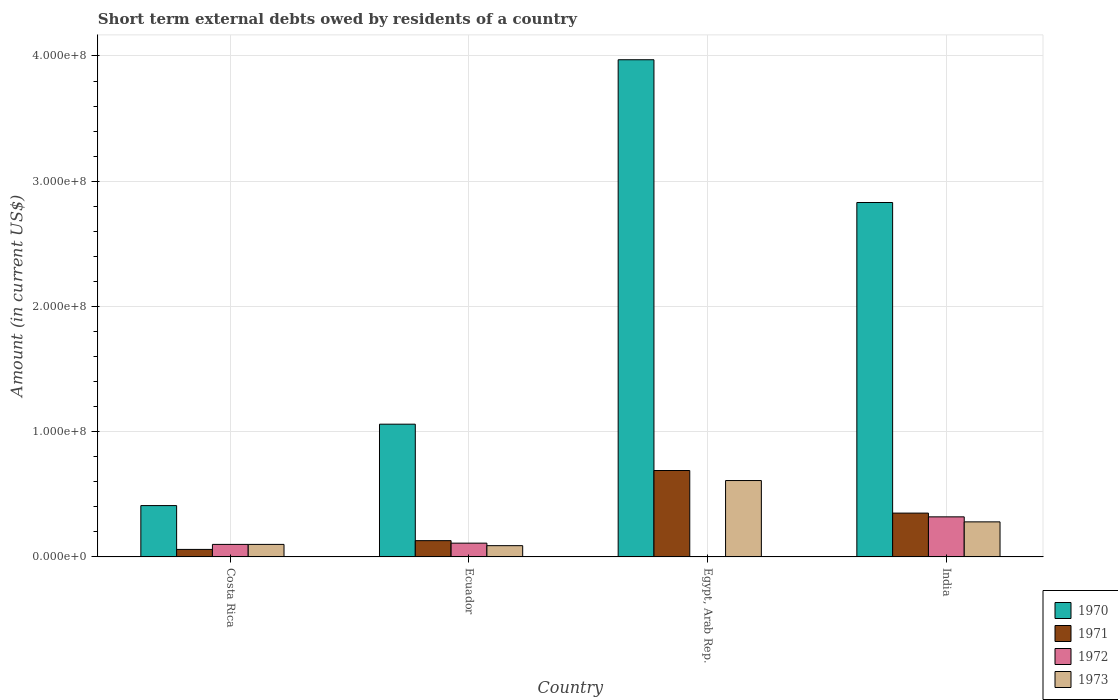How many different coloured bars are there?
Give a very brief answer. 4. Are the number of bars per tick equal to the number of legend labels?
Offer a very short reply. No. Are the number of bars on each tick of the X-axis equal?
Your answer should be very brief. No. What is the label of the 3rd group of bars from the left?
Your answer should be compact. Egypt, Arab Rep. What is the amount of short-term external debts owed by residents in 1970 in India?
Offer a terse response. 2.83e+08. Across all countries, what is the maximum amount of short-term external debts owed by residents in 1972?
Your answer should be very brief. 3.20e+07. Across all countries, what is the minimum amount of short-term external debts owed by residents in 1972?
Your answer should be very brief. 0. In which country was the amount of short-term external debts owed by residents in 1971 maximum?
Your response must be concise. Egypt, Arab Rep. What is the total amount of short-term external debts owed by residents in 1973 in the graph?
Keep it short and to the point. 1.08e+08. What is the difference between the amount of short-term external debts owed by residents in 1973 in Costa Rica and that in India?
Your response must be concise. -1.80e+07. What is the difference between the amount of short-term external debts owed by residents in 1971 in Costa Rica and the amount of short-term external debts owed by residents in 1970 in Ecuador?
Make the answer very short. -1.00e+08. What is the average amount of short-term external debts owed by residents in 1970 per country?
Keep it short and to the point. 2.07e+08. What is the difference between the amount of short-term external debts owed by residents of/in 1970 and amount of short-term external debts owed by residents of/in 1973 in India?
Offer a very short reply. 2.55e+08. What is the ratio of the amount of short-term external debts owed by residents in 1972 in Ecuador to that in India?
Offer a terse response. 0.34. What is the difference between the highest and the second highest amount of short-term external debts owed by residents in 1971?
Make the answer very short. 5.60e+07. What is the difference between the highest and the lowest amount of short-term external debts owed by residents in 1971?
Provide a short and direct response. 6.30e+07. Is the sum of the amount of short-term external debts owed by residents in 1970 in Ecuador and India greater than the maximum amount of short-term external debts owed by residents in 1972 across all countries?
Make the answer very short. Yes. Is it the case that in every country, the sum of the amount of short-term external debts owed by residents in 1971 and amount of short-term external debts owed by residents in 1973 is greater than the amount of short-term external debts owed by residents in 1972?
Give a very brief answer. Yes. How many bars are there?
Your response must be concise. 15. How many countries are there in the graph?
Your response must be concise. 4. What is the difference between two consecutive major ticks on the Y-axis?
Offer a terse response. 1.00e+08. How many legend labels are there?
Offer a terse response. 4. What is the title of the graph?
Ensure brevity in your answer.  Short term external debts owed by residents of a country. What is the label or title of the X-axis?
Provide a succinct answer. Country. What is the Amount (in current US$) of 1970 in Costa Rica?
Offer a terse response. 4.10e+07. What is the Amount (in current US$) in 1971 in Costa Rica?
Offer a very short reply. 6.00e+06. What is the Amount (in current US$) of 1970 in Ecuador?
Ensure brevity in your answer.  1.06e+08. What is the Amount (in current US$) of 1971 in Ecuador?
Make the answer very short. 1.30e+07. What is the Amount (in current US$) of 1972 in Ecuador?
Offer a terse response. 1.10e+07. What is the Amount (in current US$) of 1973 in Ecuador?
Offer a terse response. 9.00e+06. What is the Amount (in current US$) of 1970 in Egypt, Arab Rep.?
Your answer should be very brief. 3.97e+08. What is the Amount (in current US$) in 1971 in Egypt, Arab Rep.?
Provide a short and direct response. 6.90e+07. What is the Amount (in current US$) of 1973 in Egypt, Arab Rep.?
Your answer should be very brief. 6.10e+07. What is the Amount (in current US$) of 1970 in India?
Ensure brevity in your answer.  2.83e+08. What is the Amount (in current US$) in 1971 in India?
Your response must be concise. 3.50e+07. What is the Amount (in current US$) of 1972 in India?
Provide a succinct answer. 3.20e+07. What is the Amount (in current US$) in 1973 in India?
Offer a very short reply. 2.80e+07. Across all countries, what is the maximum Amount (in current US$) of 1970?
Give a very brief answer. 3.97e+08. Across all countries, what is the maximum Amount (in current US$) in 1971?
Give a very brief answer. 6.90e+07. Across all countries, what is the maximum Amount (in current US$) of 1972?
Your answer should be compact. 3.20e+07. Across all countries, what is the maximum Amount (in current US$) in 1973?
Your response must be concise. 6.10e+07. Across all countries, what is the minimum Amount (in current US$) in 1970?
Make the answer very short. 4.10e+07. Across all countries, what is the minimum Amount (in current US$) of 1971?
Keep it short and to the point. 6.00e+06. Across all countries, what is the minimum Amount (in current US$) in 1972?
Keep it short and to the point. 0. Across all countries, what is the minimum Amount (in current US$) of 1973?
Your response must be concise. 9.00e+06. What is the total Amount (in current US$) in 1970 in the graph?
Keep it short and to the point. 8.27e+08. What is the total Amount (in current US$) in 1971 in the graph?
Keep it short and to the point. 1.23e+08. What is the total Amount (in current US$) of 1972 in the graph?
Ensure brevity in your answer.  5.30e+07. What is the total Amount (in current US$) in 1973 in the graph?
Give a very brief answer. 1.08e+08. What is the difference between the Amount (in current US$) in 1970 in Costa Rica and that in Ecuador?
Your response must be concise. -6.50e+07. What is the difference between the Amount (in current US$) in 1971 in Costa Rica and that in Ecuador?
Offer a terse response. -7.00e+06. What is the difference between the Amount (in current US$) in 1970 in Costa Rica and that in Egypt, Arab Rep.?
Provide a short and direct response. -3.56e+08. What is the difference between the Amount (in current US$) of 1971 in Costa Rica and that in Egypt, Arab Rep.?
Your answer should be very brief. -6.30e+07. What is the difference between the Amount (in current US$) of 1973 in Costa Rica and that in Egypt, Arab Rep.?
Your answer should be compact. -5.10e+07. What is the difference between the Amount (in current US$) in 1970 in Costa Rica and that in India?
Offer a very short reply. -2.42e+08. What is the difference between the Amount (in current US$) in 1971 in Costa Rica and that in India?
Provide a short and direct response. -2.90e+07. What is the difference between the Amount (in current US$) of 1972 in Costa Rica and that in India?
Offer a very short reply. -2.20e+07. What is the difference between the Amount (in current US$) in 1973 in Costa Rica and that in India?
Give a very brief answer. -1.80e+07. What is the difference between the Amount (in current US$) in 1970 in Ecuador and that in Egypt, Arab Rep.?
Keep it short and to the point. -2.91e+08. What is the difference between the Amount (in current US$) of 1971 in Ecuador and that in Egypt, Arab Rep.?
Your response must be concise. -5.60e+07. What is the difference between the Amount (in current US$) of 1973 in Ecuador and that in Egypt, Arab Rep.?
Offer a terse response. -5.20e+07. What is the difference between the Amount (in current US$) in 1970 in Ecuador and that in India?
Make the answer very short. -1.77e+08. What is the difference between the Amount (in current US$) of 1971 in Ecuador and that in India?
Keep it short and to the point. -2.20e+07. What is the difference between the Amount (in current US$) in 1972 in Ecuador and that in India?
Offer a terse response. -2.10e+07. What is the difference between the Amount (in current US$) in 1973 in Ecuador and that in India?
Give a very brief answer. -1.90e+07. What is the difference between the Amount (in current US$) in 1970 in Egypt, Arab Rep. and that in India?
Your response must be concise. 1.14e+08. What is the difference between the Amount (in current US$) of 1971 in Egypt, Arab Rep. and that in India?
Your answer should be compact. 3.40e+07. What is the difference between the Amount (in current US$) in 1973 in Egypt, Arab Rep. and that in India?
Give a very brief answer. 3.30e+07. What is the difference between the Amount (in current US$) of 1970 in Costa Rica and the Amount (in current US$) of 1971 in Ecuador?
Your answer should be very brief. 2.80e+07. What is the difference between the Amount (in current US$) of 1970 in Costa Rica and the Amount (in current US$) of 1972 in Ecuador?
Ensure brevity in your answer.  3.00e+07. What is the difference between the Amount (in current US$) of 1970 in Costa Rica and the Amount (in current US$) of 1973 in Ecuador?
Make the answer very short. 3.20e+07. What is the difference between the Amount (in current US$) of 1971 in Costa Rica and the Amount (in current US$) of 1972 in Ecuador?
Offer a very short reply. -5.00e+06. What is the difference between the Amount (in current US$) of 1971 in Costa Rica and the Amount (in current US$) of 1973 in Ecuador?
Keep it short and to the point. -3.00e+06. What is the difference between the Amount (in current US$) of 1970 in Costa Rica and the Amount (in current US$) of 1971 in Egypt, Arab Rep.?
Provide a succinct answer. -2.80e+07. What is the difference between the Amount (in current US$) in 1970 in Costa Rica and the Amount (in current US$) in 1973 in Egypt, Arab Rep.?
Offer a very short reply. -2.00e+07. What is the difference between the Amount (in current US$) of 1971 in Costa Rica and the Amount (in current US$) of 1973 in Egypt, Arab Rep.?
Your answer should be very brief. -5.50e+07. What is the difference between the Amount (in current US$) in 1972 in Costa Rica and the Amount (in current US$) in 1973 in Egypt, Arab Rep.?
Your answer should be compact. -5.10e+07. What is the difference between the Amount (in current US$) in 1970 in Costa Rica and the Amount (in current US$) in 1971 in India?
Give a very brief answer. 6.00e+06. What is the difference between the Amount (in current US$) of 1970 in Costa Rica and the Amount (in current US$) of 1972 in India?
Keep it short and to the point. 9.00e+06. What is the difference between the Amount (in current US$) in 1970 in Costa Rica and the Amount (in current US$) in 1973 in India?
Your answer should be compact. 1.30e+07. What is the difference between the Amount (in current US$) of 1971 in Costa Rica and the Amount (in current US$) of 1972 in India?
Ensure brevity in your answer.  -2.60e+07. What is the difference between the Amount (in current US$) in 1971 in Costa Rica and the Amount (in current US$) in 1973 in India?
Provide a succinct answer. -2.20e+07. What is the difference between the Amount (in current US$) in 1972 in Costa Rica and the Amount (in current US$) in 1973 in India?
Provide a succinct answer. -1.80e+07. What is the difference between the Amount (in current US$) in 1970 in Ecuador and the Amount (in current US$) in 1971 in Egypt, Arab Rep.?
Provide a succinct answer. 3.70e+07. What is the difference between the Amount (in current US$) of 1970 in Ecuador and the Amount (in current US$) of 1973 in Egypt, Arab Rep.?
Your response must be concise. 4.50e+07. What is the difference between the Amount (in current US$) in 1971 in Ecuador and the Amount (in current US$) in 1973 in Egypt, Arab Rep.?
Your answer should be compact. -4.80e+07. What is the difference between the Amount (in current US$) of 1972 in Ecuador and the Amount (in current US$) of 1973 in Egypt, Arab Rep.?
Your answer should be very brief. -5.00e+07. What is the difference between the Amount (in current US$) in 1970 in Ecuador and the Amount (in current US$) in 1971 in India?
Offer a very short reply. 7.10e+07. What is the difference between the Amount (in current US$) of 1970 in Ecuador and the Amount (in current US$) of 1972 in India?
Give a very brief answer. 7.40e+07. What is the difference between the Amount (in current US$) in 1970 in Ecuador and the Amount (in current US$) in 1973 in India?
Offer a terse response. 7.80e+07. What is the difference between the Amount (in current US$) in 1971 in Ecuador and the Amount (in current US$) in 1972 in India?
Give a very brief answer. -1.90e+07. What is the difference between the Amount (in current US$) of 1971 in Ecuador and the Amount (in current US$) of 1973 in India?
Offer a very short reply. -1.50e+07. What is the difference between the Amount (in current US$) of 1972 in Ecuador and the Amount (in current US$) of 1973 in India?
Make the answer very short. -1.70e+07. What is the difference between the Amount (in current US$) of 1970 in Egypt, Arab Rep. and the Amount (in current US$) of 1971 in India?
Give a very brief answer. 3.62e+08. What is the difference between the Amount (in current US$) in 1970 in Egypt, Arab Rep. and the Amount (in current US$) in 1972 in India?
Offer a terse response. 3.65e+08. What is the difference between the Amount (in current US$) of 1970 in Egypt, Arab Rep. and the Amount (in current US$) of 1973 in India?
Your answer should be compact. 3.69e+08. What is the difference between the Amount (in current US$) in 1971 in Egypt, Arab Rep. and the Amount (in current US$) in 1972 in India?
Provide a succinct answer. 3.70e+07. What is the difference between the Amount (in current US$) in 1971 in Egypt, Arab Rep. and the Amount (in current US$) in 1973 in India?
Offer a terse response. 4.10e+07. What is the average Amount (in current US$) in 1970 per country?
Your answer should be compact. 2.07e+08. What is the average Amount (in current US$) of 1971 per country?
Your response must be concise. 3.08e+07. What is the average Amount (in current US$) of 1972 per country?
Your answer should be very brief. 1.32e+07. What is the average Amount (in current US$) of 1973 per country?
Offer a terse response. 2.70e+07. What is the difference between the Amount (in current US$) in 1970 and Amount (in current US$) in 1971 in Costa Rica?
Give a very brief answer. 3.50e+07. What is the difference between the Amount (in current US$) in 1970 and Amount (in current US$) in 1972 in Costa Rica?
Your response must be concise. 3.10e+07. What is the difference between the Amount (in current US$) in 1970 and Amount (in current US$) in 1973 in Costa Rica?
Ensure brevity in your answer.  3.10e+07. What is the difference between the Amount (in current US$) of 1971 and Amount (in current US$) of 1972 in Costa Rica?
Ensure brevity in your answer.  -4.00e+06. What is the difference between the Amount (in current US$) in 1972 and Amount (in current US$) in 1973 in Costa Rica?
Provide a short and direct response. 0. What is the difference between the Amount (in current US$) of 1970 and Amount (in current US$) of 1971 in Ecuador?
Your response must be concise. 9.30e+07. What is the difference between the Amount (in current US$) in 1970 and Amount (in current US$) in 1972 in Ecuador?
Your answer should be very brief. 9.50e+07. What is the difference between the Amount (in current US$) of 1970 and Amount (in current US$) of 1973 in Ecuador?
Offer a terse response. 9.70e+07. What is the difference between the Amount (in current US$) of 1970 and Amount (in current US$) of 1971 in Egypt, Arab Rep.?
Offer a very short reply. 3.28e+08. What is the difference between the Amount (in current US$) of 1970 and Amount (in current US$) of 1973 in Egypt, Arab Rep.?
Provide a succinct answer. 3.36e+08. What is the difference between the Amount (in current US$) of 1970 and Amount (in current US$) of 1971 in India?
Offer a terse response. 2.48e+08. What is the difference between the Amount (in current US$) of 1970 and Amount (in current US$) of 1972 in India?
Give a very brief answer. 2.51e+08. What is the difference between the Amount (in current US$) of 1970 and Amount (in current US$) of 1973 in India?
Your response must be concise. 2.55e+08. What is the difference between the Amount (in current US$) in 1971 and Amount (in current US$) in 1973 in India?
Give a very brief answer. 7.00e+06. What is the ratio of the Amount (in current US$) in 1970 in Costa Rica to that in Ecuador?
Make the answer very short. 0.39. What is the ratio of the Amount (in current US$) of 1971 in Costa Rica to that in Ecuador?
Provide a short and direct response. 0.46. What is the ratio of the Amount (in current US$) of 1973 in Costa Rica to that in Ecuador?
Make the answer very short. 1.11. What is the ratio of the Amount (in current US$) in 1970 in Costa Rica to that in Egypt, Arab Rep.?
Offer a terse response. 0.1. What is the ratio of the Amount (in current US$) in 1971 in Costa Rica to that in Egypt, Arab Rep.?
Provide a succinct answer. 0.09. What is the ratio of the Amount (in current US$) in 1973 in Costa Rica to that in Egypt, Arab Rep.?
Your response must be concise. 0.16. What is the ratio of the Amount (in current US$) in 1970 in Costa Rica to that in India?
Make the answer very short. 0.14. What is the ratio of the Amount (in current US$) of 1971 in Costa Rica to that in India?
Keep it short and to the point. 0.17. What is the ratio of the Amount (in current US$) in 1972 in Costa Rica to that in India?
Your answer should be compact. 0.31. What is the ratio of the Amount (in current US$) of 1973 in Costa Rica to that in India?
Provide a short and direct response. 0.36. What is the ratio of the Amount (in current US$) in 1970 in Ecuador to that in Egypt, Arab Rep.?
Ensure brevity in your answer.  0.27. What is the ratio of the Amount (in current US$) in 1971 in Ecuador to that in Egypt, Arab Rep.?
Your answer should be compact. 0.19. What is the ratio of the Amount (in current US$) of 1973 in Ecuador to that in Egypt, Arab Rep.?
Make the answer very short. 0.15. What is the ratio of the Amount (in current US$) in 1970 in Ecuador to that in India?
Offer a terse response. 0.37. What is the ratio of the Amount (in current US$) of 1971 in Ecuador to that in India?
Your response must be concise. 0.37. What is the ratio of the Amount (in current US$) of 1972 in Ecuador to that in India?
Your answer should be very brief. 0.34. What is the ratio of the Amount (in current US$) in 1973 in Ecuador to that in India?
Ensure brevity in your answer.  0.32. What is the ratio of the Amount (in current US$) of 1970 in Egypt, Arab Rep. to that in India?
Give a very brief answer. 1.4. What is the ratio of the Amount (in current US$) of 1971 in Egypt, Arab Rep. to that in India?
Offer a very short reply. 1.97. What is the ratio of the Amount (in current US$) of 1973 in Egypt, Arab Rep. to that in India?
Provide a succinct answer. 2.18. What is the difference between the highest and the second highest Amount (in current US$) of 1970?
Ensure brevity in your answer.  1.14e+08. What is the difference between the highest and the second highest Amount (in current US$) in 1971?
Provide a short and direct response. 3.40e+07. What is the difference between the highest and the second highest Amount (in current US$) of 1972?
Your answer should be very brief. 2.10e+07. What is the difference between the highest and the second highest Amount (in current US$) of 1973?
Your answer should be compact. 3.30e+07. What is the difference between the highest and the lowest Amount (in current US$) in 1970?
Keep it short and to the point. 3.56e+08. What is the difference between the highest and the lowest Amount (in current US$) of 1971?
Keep it short and to the point. 6.30e+07. What is the difference between the highest and the lowest Amount (in current US$) of 1972?
Provide a short and direct response. 3.20e+07. What is the difference between the highest and the lowest Amount (in current US$) in 1973?
Keep it short and to the point. 5.20e+07. 